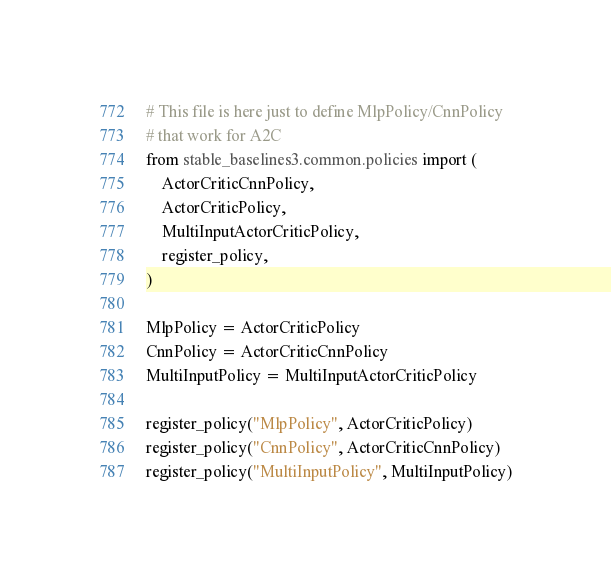Convert code to text. <code><loc_0><loc_0><loc_500><loc_500><_Python_># This file is here just to define MlpPolicy/CnnPolicy
# that work for A2C
from stable_baselines3.common.policies import (
    ActorCriticCnnPolicy,
    ActorCriticPolicy,
    MultiInputActorCriticPolicy,
    register_policy,
)

MlpPolicy = ActorCriticPolicy
CnnPolicy = ActorCriticCnnPolicy
MultiInputPolicy = MultiInputActorCriticPolicy

register_policy("MlpPolicy", ActorCriticPolicy)
register_policy("CnnPolicy", ActorCriticCnnPolicy)
register_policy("MultiInputPolicy", MultiInputPolicy)
</code> 